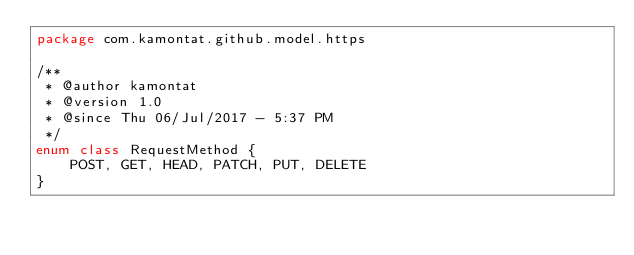<code> <loc_0><loc_0><loc_500><loc_500><_Kotlin_>package com.kamontat.github.model.https

/**
 * @author kamontat
 * @version 1.0
 * @since Thu 06/Jul/2017 - 5:37 PM
 */
enum class RequestMethod {
    POST, GET, HEAD, PATCH, PUT, DELETE
}</code> 